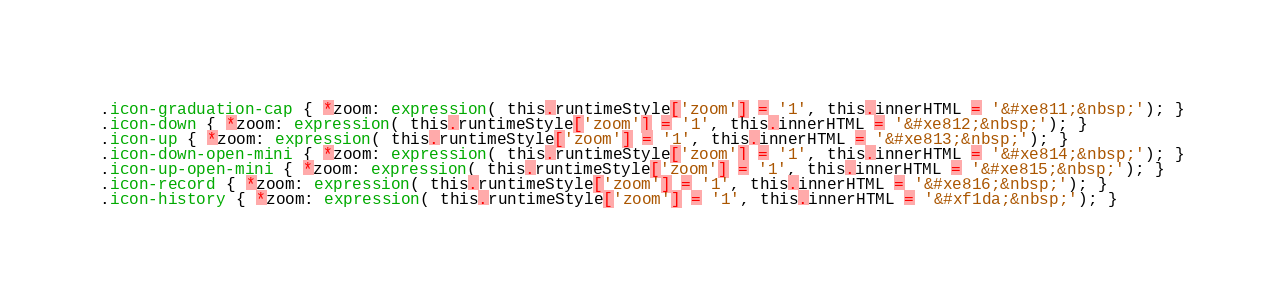<code> <loc_0><loc_0><loc_500><loc_500><_CSS_>.icon-graduation-cap { *zoom: expression( this.runtimeStyle['zoom'] = '1', this.innerHTML = '&#xe811;&nbsp;'); }
.icon-down { *zoom: expression( this.runtimeStyle['zoom'] = '1', this.innerHTML = '&#xe812;&nbsp;'); }
.icon-up { *zoom: expression( this.runtimeStyle['zoom'] = '1', this.innerHTML = '&#xe813;&nbsp;'); }
.icon-down-open-mini { *zoom: expression( this.runtimeStyle['zoom'] = '1', this.innerHTML = '&#xe814;&nbsp;'); }
.icon-up-open-mini { *zoom: expression( this.runtimeStyle['zoom'] = '1', this.innerHTML = '&#xe815;&nbsp;'); }
.icon-record { *zoom: expression( this.runtimeStyle['zoom'] = '1', this.innerHTML = '&#xe816;&nbsp;'); }
.icon-history { *zoom: expression( this.runtimeStyle['zoom'] = '1', this.innerHTML = '&#xf1da;&nbsp;'); }
</code> 